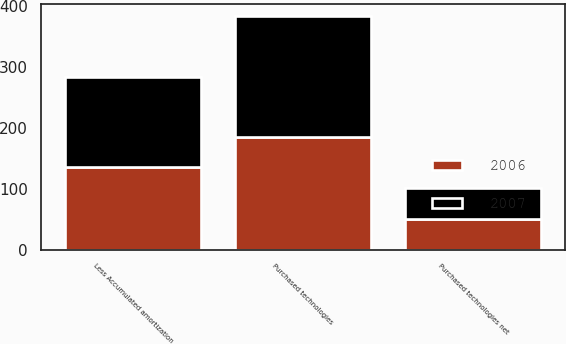Convert chart to OTSL. <chart><loc_0><loc_0><loc_500><loc_500><stacked_bar_chart><ecel><fcel>Purchased technologies<fcel>Less Accumulated amortization<fcel>Purchased technologies net<nl><fcel>2007<fcel>199.4<fcel>148.1<fcel>51.3<nl><fcel>2006<fcel>185.2<fcel>135.4<fcel>49.8<nl></chart> 